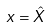Convert formula to latex. <formula><loc_0><loc_0><loc_500><loc_500>x = \hat { X }</formula> 